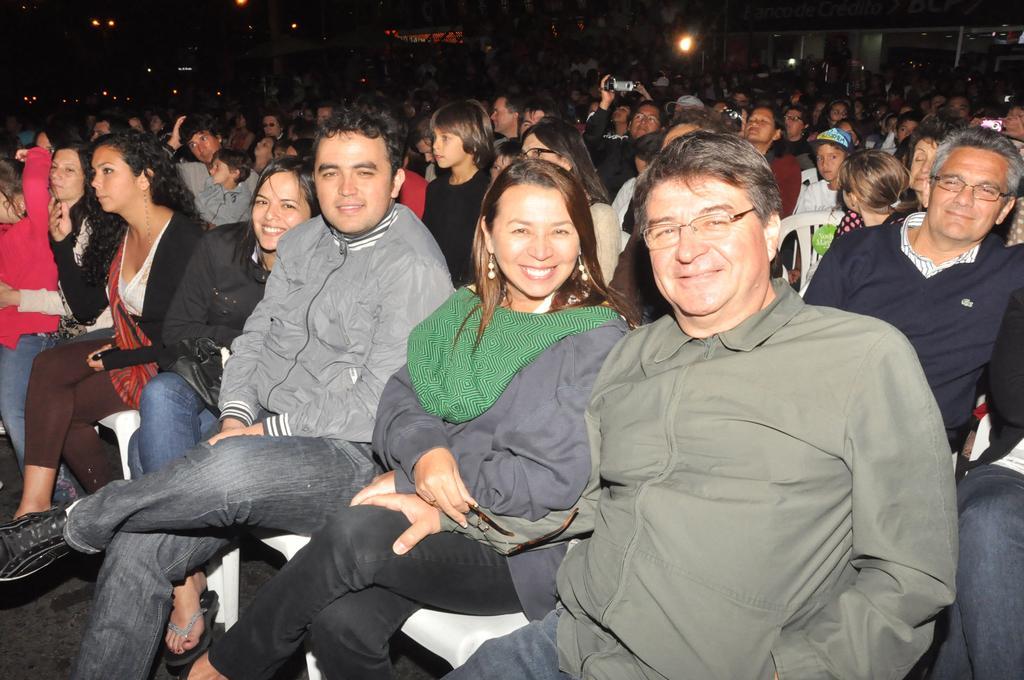Describe this image in one or two sentences. In this image we can see few persons are sitting on the chairs and a person among them is holding a camera in the hands. In the background the image is dark but we can see many people, lights and a building. 